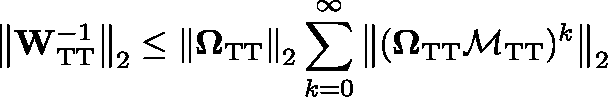<formula> <loc_0><loc_0><loc_500><loc_500>\left \| W _ { T T } ^ { - 1 } \right \| _ { 2 } \leq \left \| \Omega _ { T T } \right \| _ { 2 } \sum _ { k = 0 } ^ { \infty } \left \| ( \Omega _ { T T } \mathcal { M } _ { T T } ) ^ { k } \right \| _ { 2 }</formula> 